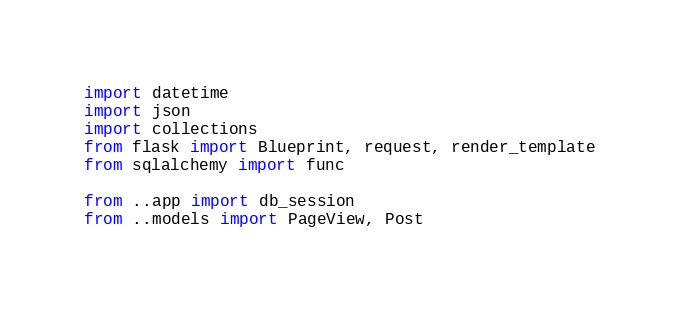<code> <loc_0><loc_0><loc_500><loc_500><_Python_>import datetime
import json
import collections
from flask import Blueprint, request, render_template
from sqlalchemy import func

from ..app import db_session
from ..models import PageView, Post</code> 